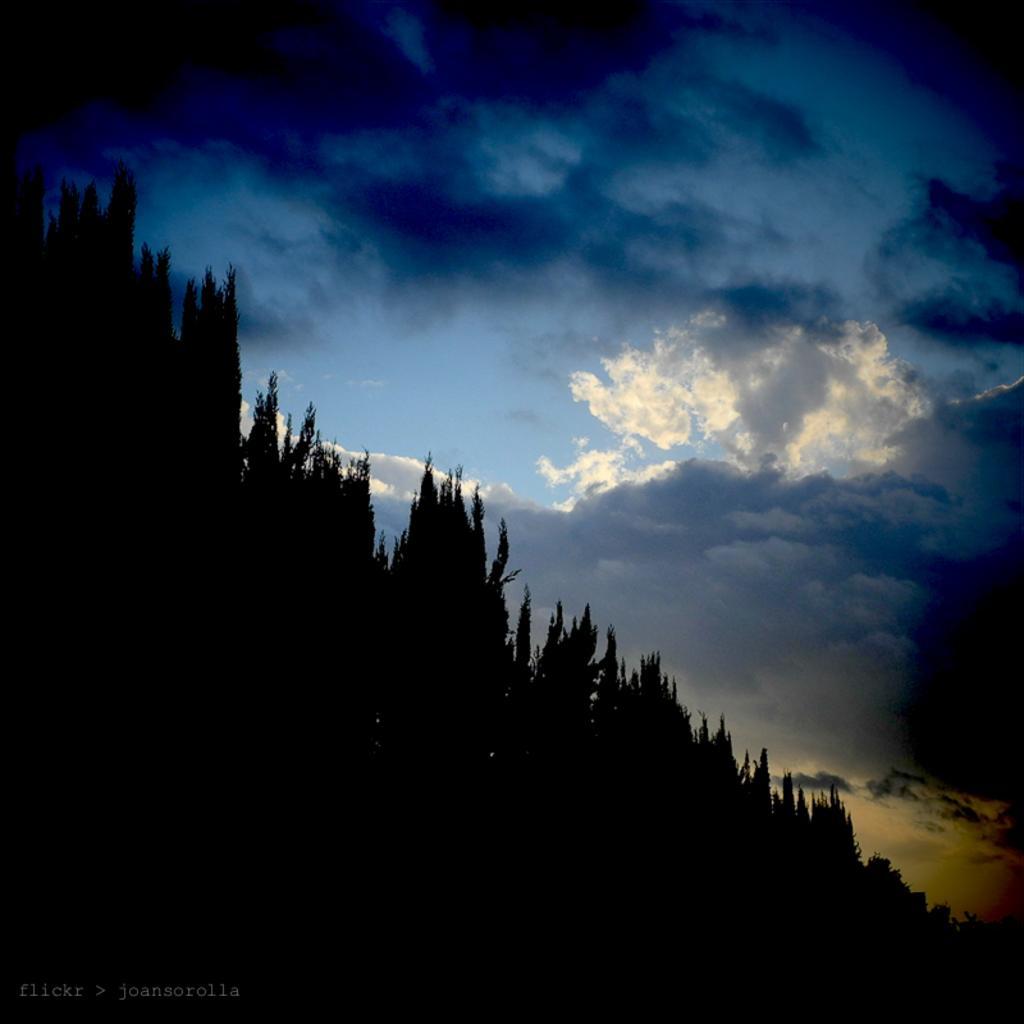In one or two sentences, can you explain what this image depicts? On the bottom left, there is a watermark. In the background, there are trees on a mountain and there are clouds in the blue sky. 